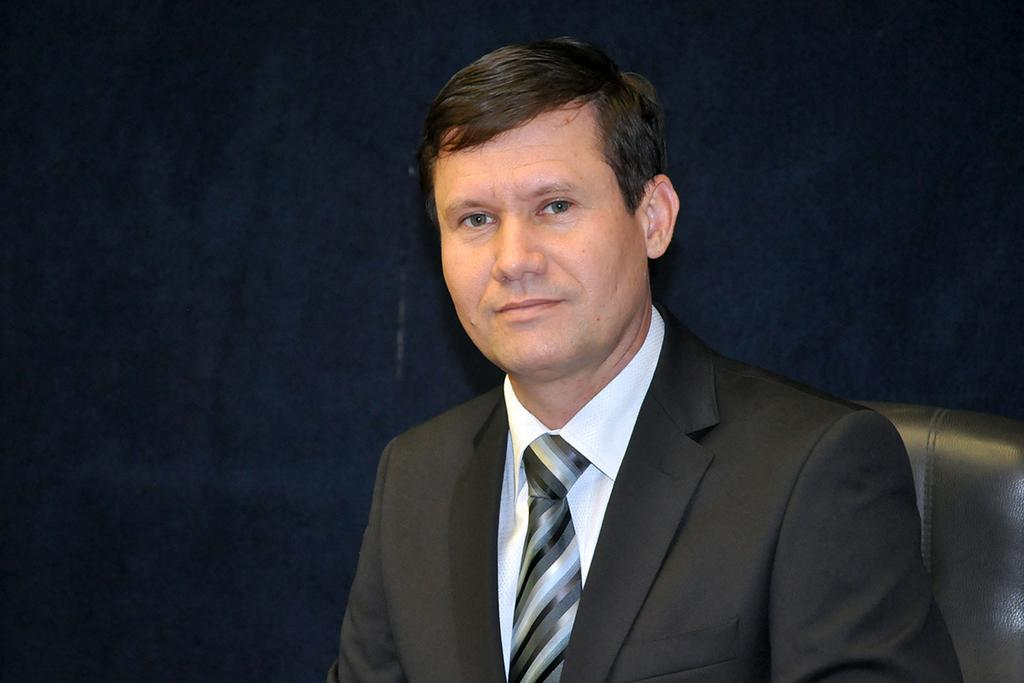What is the main subject of the image? There is a person in the image. What is the person wearing on their upper body? The person is wearing a white shirt and a black blazer. What accessory is the person wearing around their neck? The person is wearing a black tie. What is the person doing in the image? The person is sitting on a chair. What color is the chair the person is sitting on? The chair is black in color. What can be seen in the background of the image? The background of the image is black. What type of quince is being served at the person's birthday party in the image? There is no quince or birthday party present in the image; it only features a person sitting on a chair. How many men are present in the image? The image only shows one person, and there is no information about their gender, so it cannot be determined if they are a man or not. 